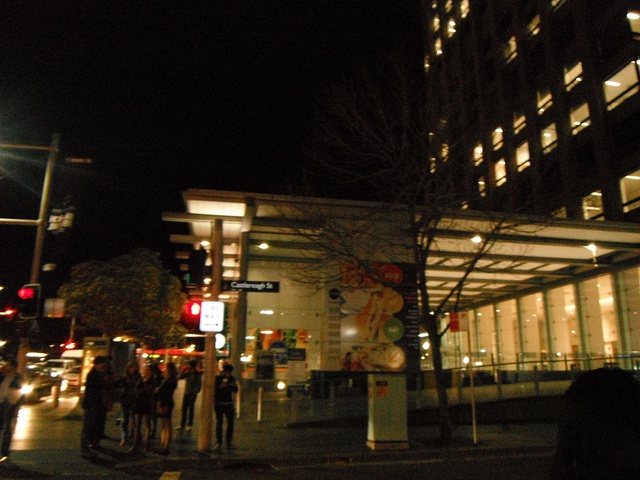Describe the objects in this image and their specific colors. I can see people in black, maroon, and olive tones, people in black, maroon, and olive tones, people in black, maroon, and olive tones, car in black, maroon, olive, and white tones, and people in black, maroon, and brown tones in this image. 